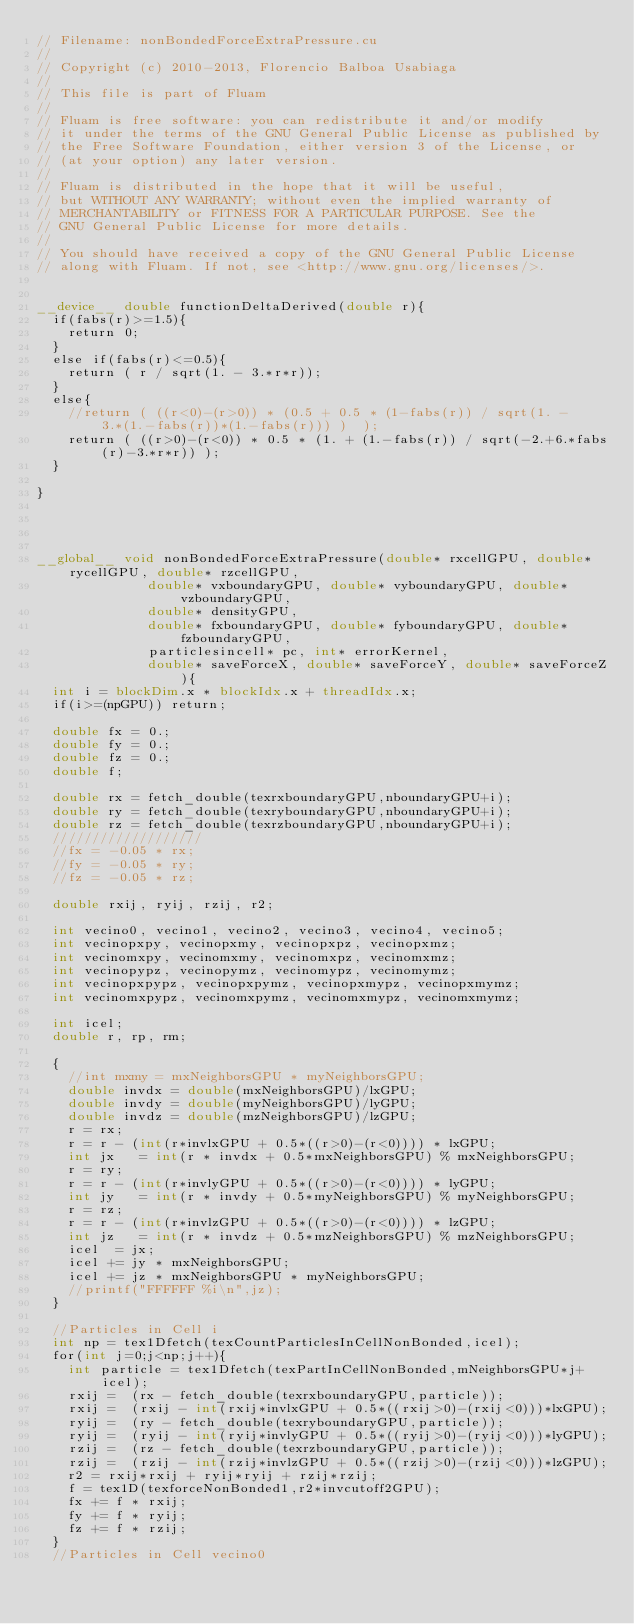Convert code to text. <code><loc_0><loc_0><loc_500><loc_500><_Cuda_>// Filename: nonBondedForceExtraPressure.cu
//
// Copyright (c) 2010-2013, Florencio Balboa Usabiaga
//
// This file is part of Fluam
//
// Fluam is free software: you can redistribute it and/or modify
// it under the terms of the GNU General Public License as published by
// the Free Software Foundation, either version 3 of the License, or
// (at your option) any later version.
//
// Fluam is distributed in the hope that it will be useful,
// but WITHOUT ANY WARRANTY; without even the implied warranty of
// MERCHANTABILITY or FITNESS FOR A PARTICULAR PURPOSE. See the
// GNU General Public License for more details.
//
// You should have received a copy of the GNU General Public License
// along with Fluam. If not, see <http://www.gnu.org/licenses/>.


__device__ double functionDeltaDerived(double r){
  if(fabs(r)>=1.5){
    return 0;
  }
  else if(fabs(r)<=0.5){
    return ( r / sqrt(1. - 3.*r*r));
  }
  else{
    //return ( ((r<0)-(r>0)) * (0.5 + 0.5 * (1-fabs(r)) / sqrt(1. - 3.*(1.-fabs(r))*(1.-fabs(r))) )  );
    return ( ((r>0)-(r<0)) * 0.5 * (1. + (1.-fabs(r)) / sqrt(-2.+6.*fabs(r)-3.*r*r)) );
  }

}




__global__ void nonBondedForceExtraPressure(double* rxcellGPU, double* rycellGPU, double* rzcellGPU,
					    double* vxboundaryGPU, double* vyboundaryGPU, double* vzboundaryGPU,
					    double* densityGPU,
					    double* fxboundaryGPU, double* fyboundaryGPU, double* fzboundaryGPU,
					    particlesincell* pc, int* errorKernel,
					    double* saveForceX, double* saveForceY, double* saveForceZ){
  int i = blockDim.x * blockIdx.x + threadIdx.x;
  if(i>=(npGPU)) return;   

  double fx = 0.;
  double fy = 0.;
  double fz = 0.;
  double f;
  
  double rx = fetch_double(texrxboundaryGPU,nboundaryGPU+i);
  double ry = fetch_double(texryboundaryGPU,nboundaryGPU+i);
  double rz = fetch_double(texrzboundaryGPU,nboundaryGPU+i);
  ///////////////////
  //fx = -0.05 * rx;
  //fy = -0.05 * ry;
  //fz = -0.05 * rz;

  double rxij, ryij, rzij, r2;

  int vecino0, vecino1, vecino2, vecino3, vecino4, vecino5;
  int vecinopxpy, vecinopxmy, vecinopxpz, vecinopxmz;
  int vecinomxpy, vecinomxmy, vecinomxpz, vecinomxmz;
  int vecinopypz, vecinopymz, vecinomypz, vecinomymz;
  int vecinopxpypz, vecinopxpymz, vecinopxmypz, vecinopxmymz;
  int vecinomxpypz, vecinomxpymz, vecinomxmypz, vecinomxmymz;
  
  int icel;
  double r, rp, rm;

  {
    //int mxmy = mxNeighborsGPU * myNeighborsGPU;
    double invdx = double(mxNeighborsGPU)/lxGPU;
    double invdy = double(myNeighborsGPU)/lyGPU;
    double invdz = double(mzNeighborsGPU)/lzGPU;
    r = rx;
    r = r - (int(r*invlxGPU + 0.5*((r>0)-(r<0)))) * lxGPU;
    int jx   = int(r * invdx + 0.5*mxNeighborsGPU) % mxNeighborsGPU;
    r = ry;
    r = r - (int(r*invlyGPU + 0.5*((r>0)-(r<0)))) * lyGPU;
    int jy   = int(r * invdy + 0.5*myNeighborsGPU) % myNeighborsGPU;
    r = rz;
    r = r - (int(r*invlzGPU + 0.5*((r>0)-(r<0)))) * lzGPU;
    int jz   = int(r * invdz + 0.5*mzNeighborsGPU) % mzNeighborsGPU;
    icel  = jx;
    icel += jy * mxNeighborsGPU;
    icel += jz * mxNeighborsGPU * myNeighborsGPU;    
    //printf("FFFFFF %i\n",jz);
  }
  
  //Particles in Cell i
  int np = tex1Dfetch(texCountParticlesInCellNonBonded,icel);
  for(int j=0;j<np;j++){
    int particle = tex1Dfetch(texPartInCellNonBonded,mNeighborsGPU*j+icel);
    rxij =  (rx - fetch_double(texrxboundaryGPU,particle));
    rxij =  (rxij - int(rxij*invlxGPU + 0.5*((rxij>0)-(rxij<0)))*lxGPU);
    ryij =  (ry - fetch_double(texryboundaryGPU,particle));
    ryij =  (ryij - int(ryij*invlyGPU + 0.5*((ryij>0)-(ryij<0)))*lyGPU);
    rzij =  (rz - fetch_double(texrzboundaryGPU,particle));
    rzij =  (rzij - int(rzij*invlzGPU + 0.5*((rzij>0)-(rzij<0)))*lzGPU);
    r2 = rxij*rxij + ryij*ryij + rzij*rzij;
    f = tex1D(texforceNonBonded1,r2*invcutoff2GPU);
    fx += f * rxij;
    fy += f * ryij;
    fz += f * rzij;
  }  
  //Particles in Cell vecino0</code> 